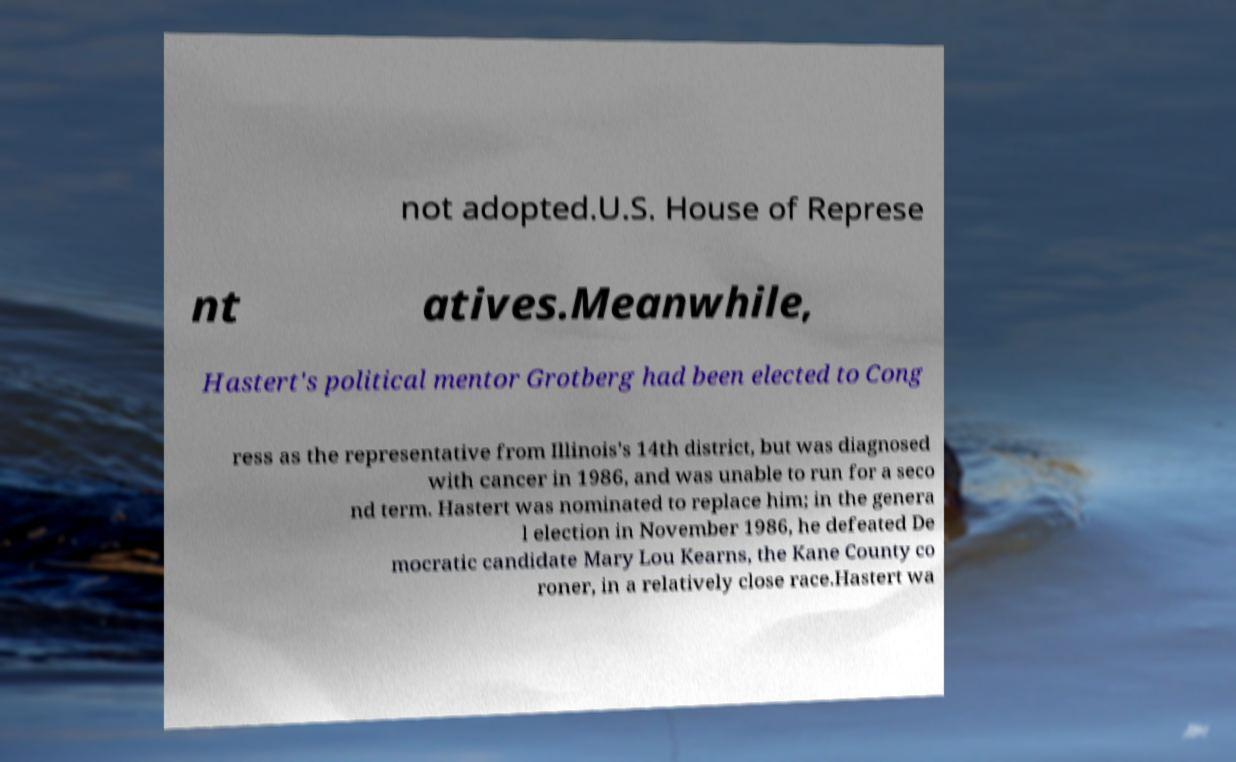What messages or text are displayed in this image? I need them in a readable, typed format. not adopted.U.S. House of Represe nt atives.Meanwhile, Hastert's political mentor Grotberg had been elected to Cong ress as the representative from Illinois's 14th district, but was diagnosed with cancer in 1986, and was unable to run for a seco nd term. Hastert was nominated to replace him; in the genera l election in November 1986, he defeated De mocratic candidate Mary Lou Kearns, the Kane County co roner, in a relatively close race.Hastert wa 